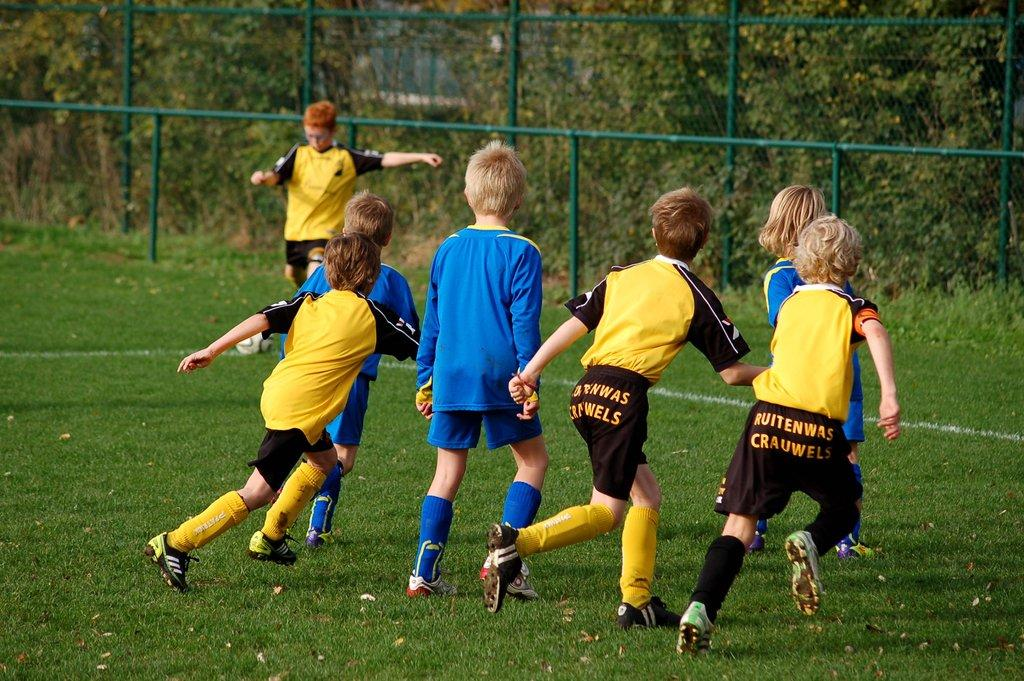<image>
Present a compact description of the photo's key features. Childrens soccer team called Ruitenwas Crauwels wearing black and yellow uniforms. 